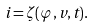<formula> <loc_0><loc_0><loc_500><loc_500>i = \zeta ( \varphi , v , t ) .</formula> 